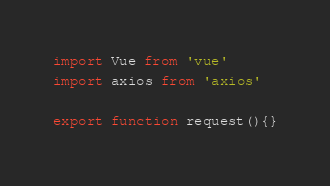<code> <loc_0><loc_0><loc_500><loc_500><_JavaScript_>import Vue from 'vue'
import axios from 'axios'

export function request(){}</code> 